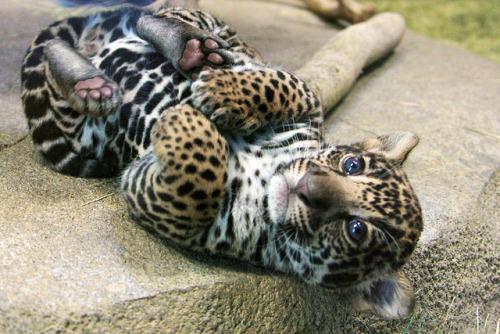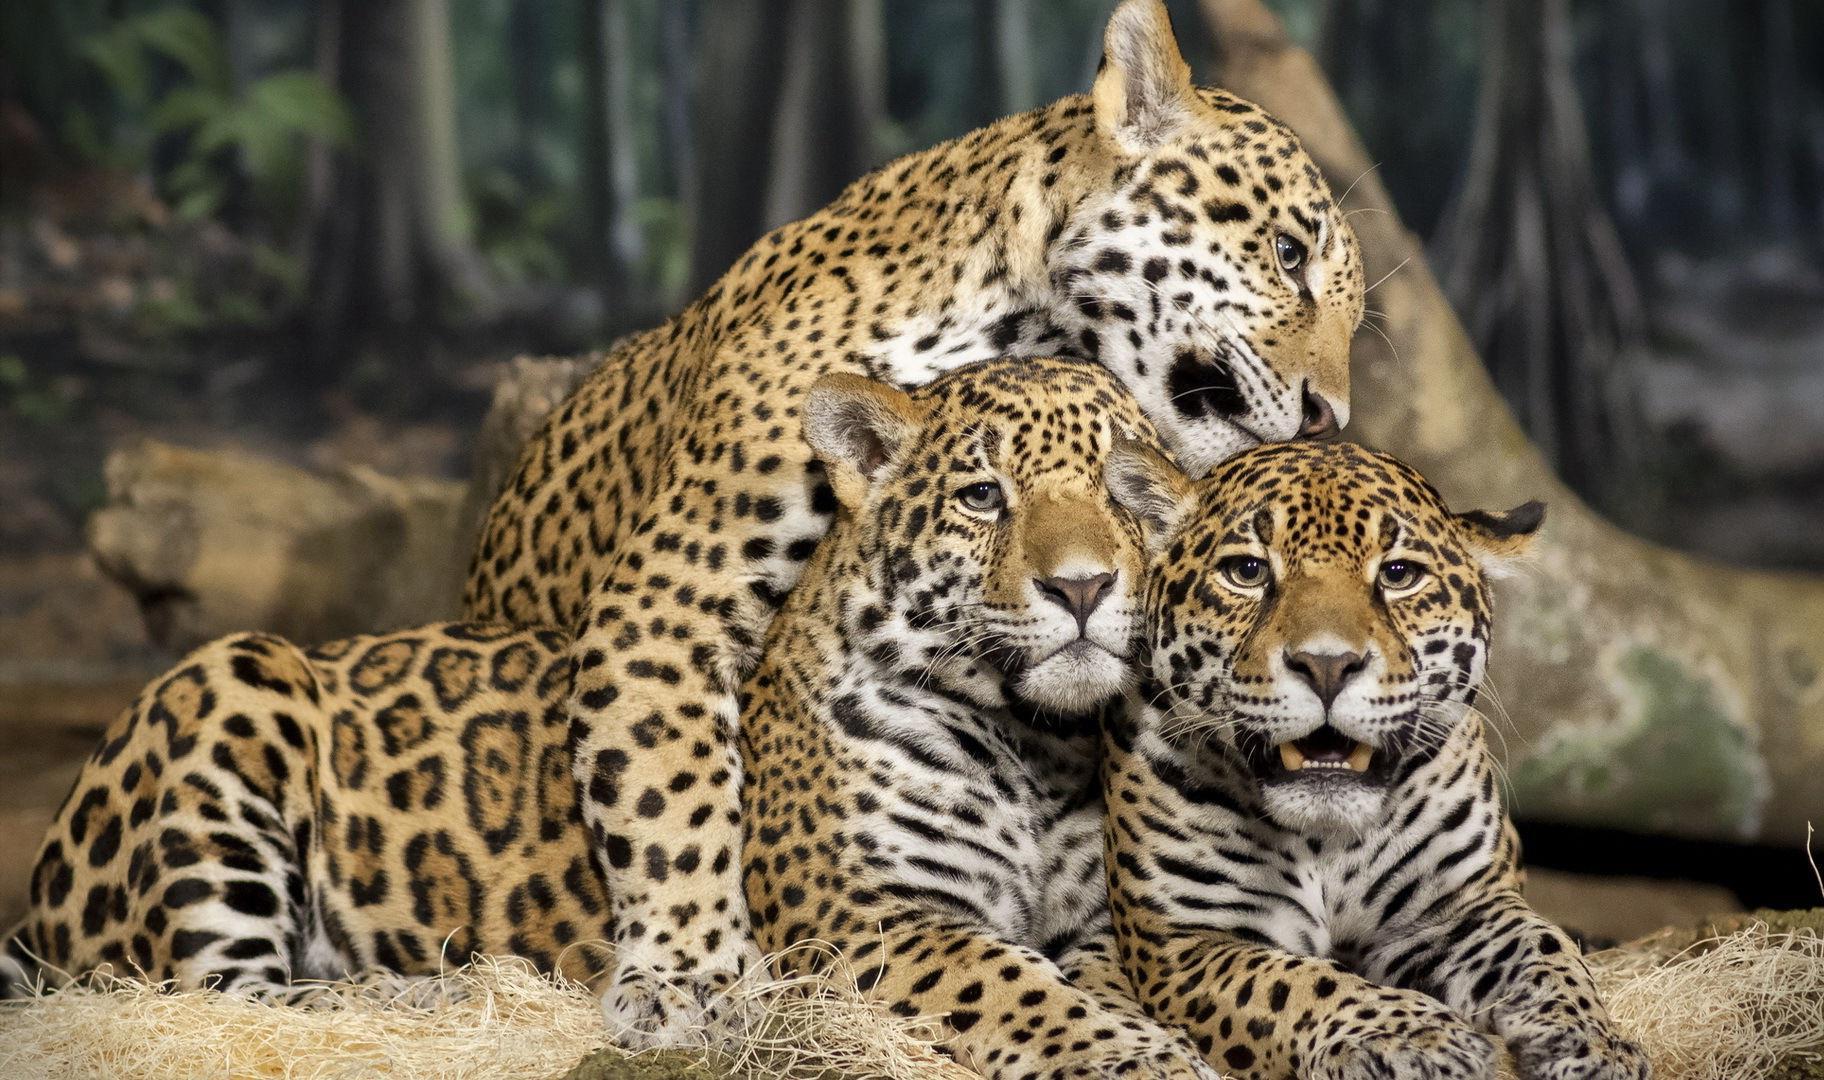The first image is the image on the left, the second image is the image on the right. Considering the images on both sides, is "At least one image shows a group of at least three spotted cats, clustered together." valid? Answer yes or no. Yes. The first image is the image on the left, the second image is the image on the right. For the images shown, is this caption "there are at least three animals in the image on the left." true? Answer yes or no. No. 